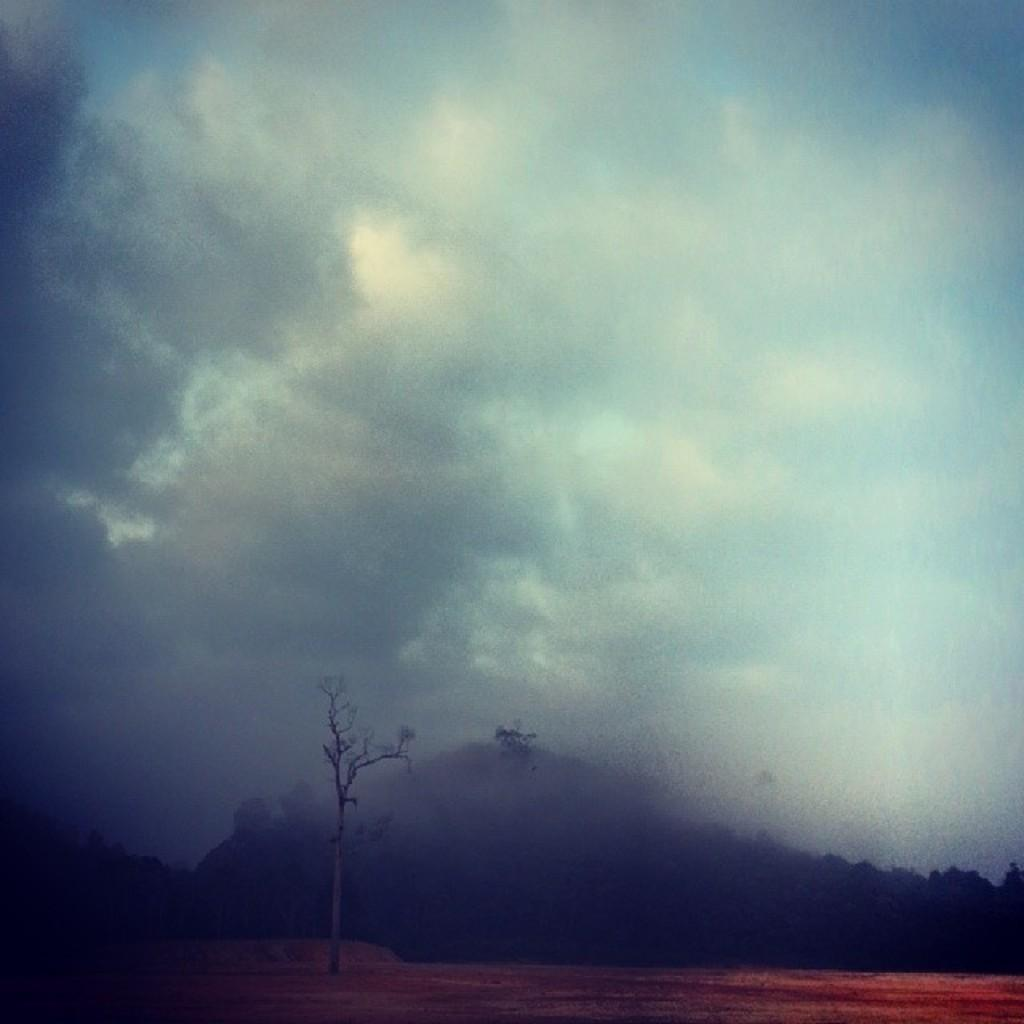What can be seen in the background of the image? The sky is visible in the image, and clouds are present in the sky. What type of natural features are present in the image? There are trees and hills in the image. What is visible at the bottom of the image? The ground is visible in the image. Can you see any jelly on the stage in the image? There is no jelly or stage present in the image. Is there a yak grazing on the hills in the image? There is no yak visible in the image. 